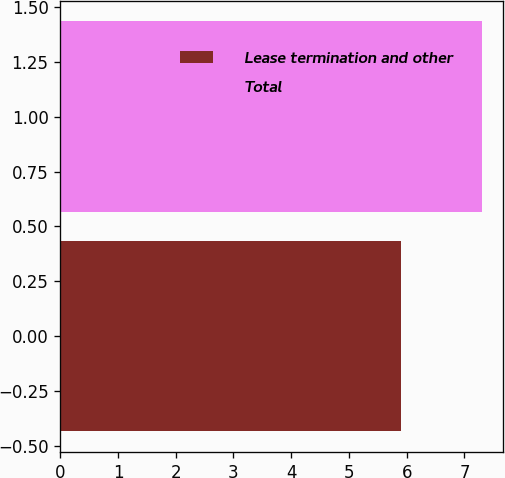<chart> <loc_0><loc_0><loc_500><loc_500><bar_chart><fcel>Lease termination and other<fcel>Total<nl><fcel>5.9<fcel>7.3<nl></chart> 